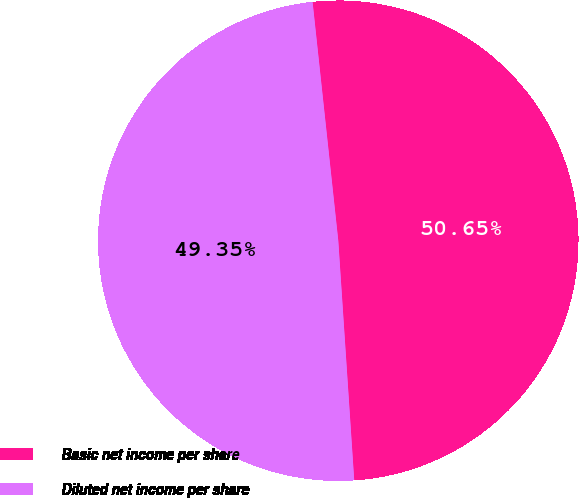Convert chart to OTSL. <chart><loc_0><loc_0><loc_500><loc_500><pie_chart><fcel>Basic net income per share<fcel>Diluted net income per share<nl><fcel>50.65%<fcel>49.35%<nl></chart> 